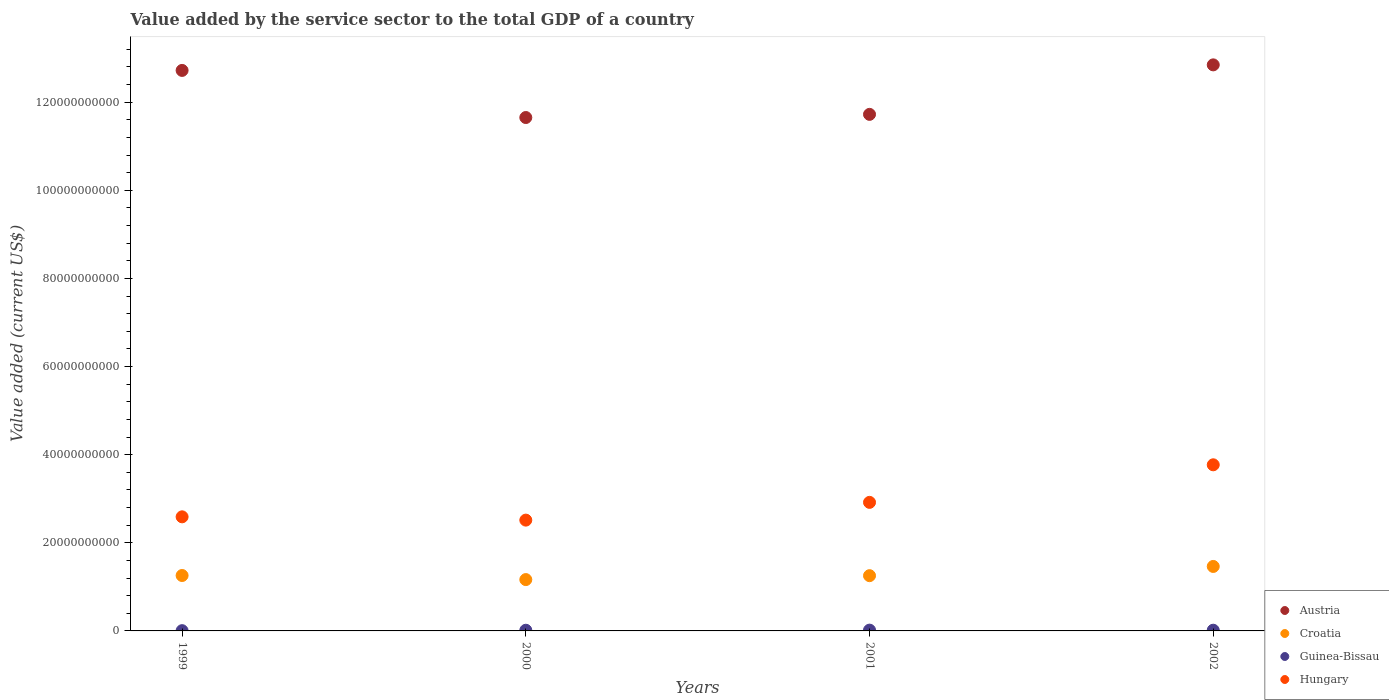How many different coloured dotlines are there?
Your response must be concise. 4. Is the number of dotlines equal to the number of legend labels?
Your answer should be compact. Yes. What is the value added by the service sector to the total GDP in Croatia in 2002?
Offer a very short reply. 1.46e+1. Across all years, what is the maximum value added by the service sector to the total GDP in Austria?
Your answer should be very brief. 1.28e+11. Across all years, what is the minimum value added by the service sector to the total GDP in Guinea-Bissau?
Keep it short and to the point. 5.98e+07. In which year was the value added by the service sector to the total GDP in Guinea-Bissau maximum?
Keep it short and to the point. 2001. In which year was the value added by the service sector to the total GDP in Guinea-Bissau minimum?
Provide a short and direct response. 1999. What is the total value added by the service sector to the total GDP in Guinea-Bissau in the graph?
Your response must be concise. 5.57e+08. What is the difference between the value added by the service sector to the total GDP in Guinea-Bissau in 1999 and that in 2001?
Provide a short and direct response. -1.21e+08. What is the difference between the value added by the service sector to the total GDP in Croatia in 2002 and the value added by the service sector to the total GDP in Austria in 1999?
Give a very brief answer. -1.13e+11. What is the average value added by the service sector to the total GDP in Guinea-Bissau per year?
Provide a succinct answer. 1.39e+08. In the year 2002, what is the difference between the value added by the service sector to the total GDP in Hungary and value added by the service sector to the total GDP in Austria?
Offer a very short reply. -9.08e+1. What is the ratio of the value added by the service sector to the total GDP in Guinea-Bissau in 2000 to that in 2001?
Provide a succinct answer. 0.86. Is the difference between the value added by the service sector to the total GDP in Hungary in 2001 and 2002 greater than the difference between the value added by the service sector to the total GDP in Austria in 2001 and 2002?
Give a very brief answer. Yes. What is the difference between the highest and the second highest value added by the service sector to the total GDP in Austria?
Offer a very short reply. 1.26e+09. What is the difference between the highest and the lowest value added by the service sector to the total GDP in Guinea-Bissau?
Ensure brevity in your answer.  1.21e+08. Is it the case that in every year, the sum of the value added by the service sector to the total GDP in Austria and value added by the service sector to the total GDP in Guinea-Bissau  is greater than the sum of value added by the service sector to the total GDP in Croatia and value added by the service sector to the total GDP in Hungary?
Provide a short and direct response. No. Is it the case that in every year, the sum of the value added by the service sector to the total GDP in Croatia and value added by the service sector to the total GDP in Guinea-Bissau  is greater than the value added by the service sector to the total GDP in Hungary?
Provide a succinct answer. No. Does the value added by the service sector to the total GDP in Croatia monotonically increase over the years?
Keep it short and to the point. No. Is the value added by the service sector to the total GDP in Austria strictly greater than the value added by the service sector to the total GDP in Guinea-Bissau over the years?
Ensure brevity in your answer.  Yes. How many dotlines are there?
Make the answer very short. 4. How many years are there in the graph?
Your answer should be compact. 4. What is the difference between two consecutive major ticks on the Y-axis?
Provide a short and direct response. 2.00e+1. Are the values on the major ticks of Y-axis written in scientific E-notation?
Give a very brief answer. No. Does the graph contain grids?
Provide a short and direct response. No. Where does the legend appear in the graph?
Your answer should be very brief. Bottom right. How are the legend labels stacked?
Your answer should be compact. Vertical. What is the title of the graph?
Your response must be concise. Value added by the service sector to the total GDP of a country. Does "Mexico" appear as one of the legend labels in the graph?
Provide a short and direct response. No. What is the label or title of the X-axis?
Provide a succinct answer. Years. What is the label or title of the Y-axis?
Your answer should be very brief. Value added (current US$). What is the Value added (current US$) of Austria in 1999?
Provide a short and direct response. 1.27e+11. What is the Value added (current US$) of Croatia in 1999?
Give a very brief answer. 1.26e+1. What is the Value added (current US$) of Guinea-Bissau in 1999?
Your response must be concise. 5.98e+07. What is the Value added (current US$) in Hungary in 1999?
Your answer should be very brief. 2.59e+1. What is the Value added (current US$) in Austria in 2000?
Offer a very short reply. 1.17e+11. What is the Value added (current US$) in Croatia in 2000?
Provide a succinct answer. 1.17e+1. What is the Value added (current US$) in Guinea-Bissau in 2000?
Your answer should be compact. 1.55e+08. What is the Value added (current US$) of Hungary in 2000?
Your answer should be very brief. 2.51e+1. What is the Value added (current US$) in Austria in 2001?
Your answer should be compact. 1.17e+11. What is the Value added (current US$) of Croatia in 2001?
Keep it short and to the point. 1.25e+1. What is the Value added (current US$) of Guinea-Bissau in 2001?
Your answer should be very brief. 1.81e+08. What is the Value added (current US$) in Hungary in 2001?
Your answer should be compact. 2.92e+1. What is the Value added (current US$) of Austria in 2002?
Keep it short and to the point. 1.28e+11. What is the Value added (current US$) in Croatia in 2002?
Make the answer very short. 1.46e+1. What is the Value added (current US$) in Guinea-Bissau in 2002?
Provide a short and direct response. 1.61e+08. What is the Value added (current US$) of Hungary in 2002?
Give a very brief answer. 3.77e+1. Across all years, what is the maximum Value added (current US$) in Austria?
Offer a very short reply. 1.28e+11. Across all years, what is the maximum Value added (current US$) in Croatia?
Your response must be concise. 1.46e+1. Across all years, what is the maximum Value added (current US$) of Guinea-Bissau?
Your answer should be compact. 1.81e+08. Across all years, what is the maximum Value added (current US$) of Hungary?
Provide a succinct answer. 3.77e+1. Across all years, what is the minimum Value added (current US$) in Austria?
Offer a terse response. 1.17e+11. Across all years, what is the minimum Value added (current US$) of Croatia?
Ensure brevity in your answer.  1.17e+1. Across all years, what is the minimum Value added (current US$) of Guinea-Bissau?
Offer a terse response. 5.98e+07. Across all years, what is the minimum Value added (current US$) of Hungary?
Provide a short and direct response. 2.51e+1. What is the total Value added (current US$) in Austria in the graph?
Keep it short and to the point. 4.89e+11. What is the total Value added (current US$) of Croatia in the graph?
Ensure brevity in your answer.  5.14e+1. What is the total Value added (current US$) in Guinea-Bissau in the graph?
Ensure brevity in your answer.  5.57e+08. What is the total Value added (current US$) of Hungary in the graph?
Provide a succinct answer. 1.18e+11. What is the difference between the Value added (current US$) of Austria in 1999 and that in 2000?
Provide a short and direct response. 1.07e+1. What is the difference between the Value added (current US$) in Croatia in 1999 and that in 2000?
Ensure brevity in your answer.  9.26e+08. What is the difference between the Value added (current US$) of Guinea-Bissau in 1999 and that in 2000?
Offer a very short reply. -9.49e+07. What is the difference between the Value added (current US$) of Hungary in 1999 and that in 2000?
Give a very brief answer. 7.47e+08. What is the difference between the Value added (current US$) of Austria in 1999 and that in 2001?
Your answer should be compact. 9.97e+09. What is the difference between the Value added (current US$) of Croatia in 1999 and that in 2001?
Offer a very short reply. 3.69e+07. What is the difference between the Value added (current US$) in Guinea-Bissau in 1999 and that in 2001?
Your response must be concise. -1.21e+08. What is the difference between the Value added (current US$) in Hungary in 1999 and that in 2001?
Your response must be concise. -3.28e+09. What is the difference between the Value added (current US$) of Austria in 1999 and that in 2002?
Your answer should be compact. -1.26e+09. What is the difference between the Value added (current US$) of Croatia in 1999 and that in 2002?
Offer a terse response. -2.06e+09. What is the difference between the Value added (current US$) of Guinea-Bissau in 1999 and that in 2002?
Your answer should be very brief. -1.02e+08. What is the difference between the Value added (current US$) in Hungary in 1999 and that in 2002?
Ensure brevity in your answer.  -1.18e+1. What is the difference between the Value added (current US$) in Austria in 2000 and that in 2001?
Provide a succinct answer. -7.18e+08. What is the difference between the Value added (current US$) in Croatia in 2000 and that in 2001?
Your answer should be very brief. -8.89e+08. What is the difference between the Value added (current US$) of Guinea-Bissau in 2000 and that in 2001?
Provide a short and direct response. -2.60e+07. What is the difference between the Value added (current US$) in Hungary in 2000 and that in 2001?
Give a very brief answer. -4.03e+09. What is the difference between the Value added (current US$) of Austria in 2000 and that in 2002?
Your answer should be very brief. -1.20e+1. What is the difference between the Value added (current US$) in Croatia in 2000 and that in 2002?
Your answer should be compact. -2.98e+09. What is the difference between the Value added (current US$) in Guinea-Bissau in 2000 and that in 2002?
Keep it short and to the point. -6.68e+06. What is the difference between the Value added (current US$) of Hungary in 2000 and that in 2002?
Your answer should be very brief. -1.26e+1. What is the difference between the Value added (current US$) of Austria in 2001 and that in 2002?
Your answer should be very brief. -1.12e+1. What is the difference between the Value added (current US$) of Croatia in 2001 and that in 2002?
Provide a short and direct response. -2.09e+09. What is the difference between the Value added (current US$) in Guinea-Bissau in 2001 and that in 2002?
Give a very brief answer. 1.93e+07. What is the difference between the Value added (current US$) of Hungary in 2001 and that in 2002?
Provide a short and direct response. -8.53e+09. What is the difference between the Value added (current US$) of Austria in 1999 and the Value added (current US$) of Croatia in 2000?
Your answer should be compact. 1.16e+11. What is the difference between the Value added (current US$) in Austria in 1999 and the Value added (current US$) in Guinea-Bissau in 2000?
Offer a very short reply. 1.27e+11. What is the difference between the Value added (current US$) of Austria in 1999 and the Value added (current US$) of Hungary in 2000?
Give a very brief answer. 1.02e+11. What is the difference between the Value added (current US$) of Croatia in 1999 and the Value added (current US$) of Guinea-Bissau in 2000?
Your answer should be compact. 1.24e+1. What is the difference between the Value added (current US$) in Croatia in 1999 and the Value added (current US$) in Hungary in 2000?
Keep it short and to the point. -1.26e+1. What is the difference between the Value added (current US$) of Guinea-Bissau in 1999 and the Value added (current US$) of Hungary in 2000?
Make the answer very short. -2.51e+1. What is the difference between the Value added (current US$) in Austria in 1999 and the Value added (current US$) in Croatia in 2001?
Your response must be concise. 1.15e+11. What is the difference between the Value added (current US$) in Austria in 1999 and the Value added (current US$) in Guinea-Bissau in 2001?
Provide a succinct answer. 1.27e+11. What is the difference between the Value added (current US$) in Austria in 1999 and the Value added (current US$) in Hungary in 2001?
Make the answer very short. 9.80e+1. What is the difference between the Value added (current US$) in Croatia in 1999 and the Value added (current US$) in Guinea-Bissau in 2001?
Keep it short and to the point. 1.24e+1. What is the difference between the Value added (current US$) of Croatia in 1999 and the Value added (current US$) of Hungary in 2001?
Give a very brief answer. -1.66e+1. What is the difference between the Value added (current US$) in Guinea-Bissau in 1999 and the Value added (current US$) in Hungary in 2001?
Your response must be concise. -2.91e+1. What is the difference between the Value added (current US$) of Austria in 1999 and the Value added (current US$) of Croatia in 2002?
Provide a succinct answer. 1.13e+11. What is the difference between the Value added (current US$) in Austria in 1999 and the Value added (current US$) in Guinea-Bissau in 2002?
Give a very brief answer. 1.27e+11. What is the difference between the Value added (current US$) in Austria in 1999 and the Value added (current US$) in Hungary in 2002?
Offer a terse response. 8.95e+1. What is the difference between the Value added (current US$) in Croatia in 1999 and the Value added (current US$) in Guinea-Bissau in 2002?
Provide a short and direct response. 1.24e+1. What is the difference between the Value added (current US$) in Croatia in 1999 and the Value added (current US$) in Hungary in 2002?
Offer a terse response. -2.51e+1. What is the difference between the Value added (current US$) of Guinea-Bissau in 1999 and the Value added (current US$) of Hungary in 2002?
Offer a terse response. -3.76e+1. What is the difference between the Value added (current US$) in Austria in 2000 and the Value added (current US$) in Croatia in 2001?
Give a very brief answer. 1.04e+11. What is the difference between the Value added (current US$) in Austria in 2000 and the Value added (current US$) in Guinea-Bissau in 2001?
Your answer should be very brief. 1.16e+11. What is the difference between the Value added (current US$) in Austria in 2000 and the Value added (current US$) in Hungary in 2001?
Your answer should be compact. 8.73e+1. What is the difference between the Value added (current US$) in Croatia in 2000 and the Value added (current US$) in Guinea-Bissau in 2001?
Give a very brief answer. 1.15e+1. What is the difference between the Value added (current US$) of Croatia in 2000 and the Value added (current US$) of Hungary in 2001?
Your response must be concise. -1.75e+1. What is the difference between the Value added (current US$) of Guinea-Bissau in 2000 and the Value added (current US$) of Hungary in 2001?
Your answer should be compact. -2.90e+1. What is the difference between the Value added (current US$) of Austria in 2000 and the Value added (current US$) of Croatia in 2002?
Offer a terse response. 1.02e+11. What is the difference between the Value added (current US$) in Austria in 2000 and the Value added (current US$) in Guinea-Bissau in 2002?
Keep it short and to the point. 1.16e+11. What is the difference between the Value added (current US$) in Austria in 2000 and the Value added (current US$) in Hungary in 2002?
Provide a short and direct response. 7.88e+1. What is the difference between the Value added (current US$) of Croatia in 2000 and the Value added (current US$) of Guinea-Bissau in 2002?
Keep it short and to the point. 1.15e+1. What is the difference between the Value added (current US$) in Croatia in 2000 and the Value added (current US$) in Hungary in 2002?
Give a very brief answer. -2.61e+1. What is the difference between the Value added (current US$) of Guinea-Bissau in 2000 and the Value added (current US$) of Hungary in 2002?
Offer a very short reply. -3.76e+1. What is the difference between the Value added (current US$) in Austria in 2001 and the Value added (current US$) in Croatia in 2002?
Provide a short and direct response. 1.03e+11. What is the difference between the Value added (current US$) in Austria in 2001 and the Value added (current US$) in Guinea-Bissau in 2002?
Your answer should be very brief. 1.17e+11. What is the difference between the Value added (current US$) of Austria in 2001 and the Value added (current US$) of Hungary in 2002?
Your response must be concise. 7.95e+1. What is the difference between the Value added (current US$) of Croatia in 2001 and the Value added (current US$) of Guinea-Bissau in 2002?
Your answer should be compact. 1.24e+1. What is the difference between the Value added (current US$) of Croatia in 2001 and the Value added (current US$) of Hungary in 2002?
Give a very brief answer. -2.52e+1. What is the difference between the Value added (current US$) of Guinea-Bissau in 2001 and the Value added (current US$) of Hungary in 2002?
Give a very brief answer. -3.75e+1. What is the average Value added (current US$) in Austria per year?
Your answer should be very brief. 1.22e+11. What is the average Value added (current US$) in Croatia per year?
Keep it short and to the point. 1.29e+1. What is the average Value added (current US$) of Guinea-Bissau per year?
Your answer should be very brief. 1.39e+08. What is the average Value added (current US$) of Hungary per year?
Offer a very short reply. 2.95e+1. In the year 1999, what is the difference between the Value added (current US$) in Austria and Value added (current US$) in Croatia?
Your answer should be compact. 1.15e+11. In the year 1999, what is the difference between the Value added (current US$) in Austria and Value added (current US$) in Guinea-Bissau?
Make the answer very short. 1.27e+11. In the year 1999, what is the difference between the Value added (current US$) of Austria and Value added (current US$) of Hungary?
Make the answer very short. 1.01e+11. In the year 1999, what is the difference between the Value added (current US$) of Croatia and Value added (current US$) of Guinea-Bissau?
Your answer should be very brief. 1.25e+1. In the year 1999, what is the difference between the Value added (current US$) in Croatia and Value added (current US$) in Hungary?
Keep it short and to the point. -1.33e+1. In the year 1999, what is the difference between the Value added (current US$) of Guinea-Bissau and Value added (current US$) of Hungary?
Ensure brevity in your answer.  -2.58e+1. In the year 2000, what is the difference between the Value added (current US$) in Austria and Value added (current US$) in Croatia?
Ensure brevity in your answer.  1.05e+11. In the year 2000, what is the difference between the Value added (current US$) in Austria and Value added (current US$) in Guinea-Bissau?
Your answer should be very brief. 1.16e+11. In the year 2000, what is the difference between the Value added (current US$) of Austria and Value added (current US$) of Hungary?
Give a very brief answer. 9.14e+1. In the year 2000, what is the difference between the Value added (current US$) in Croatia and Value added (current US$) in Guinea-Bissau?
Provide a succinct answer. 1.15e+1. In the year 2000, what is the difference between the Value added (current US$) of Croatia and Value added (current US$) of Hungary?
Your answer should be very brief. -1.35e+1. In the year 2000, what is the difference between the Value added (current US$) in Guinea-Bissau and Value added (current US$) in Hungary?
Your answer should be compact. -2.50e+1. In the year 2001, what is the difference between the Value added (current US$) in Austria and Value added (current US$) in Croatia?
Provide a short and direct response. 1.05e+11. In the year 2001, what is the difference between the Value added (current US$) of Austria and Value added (current US$) of Guinea-Bissau?
Your answer should be very brief. 1.17e+11. In the year 2001, what is the difference between the Value added (current US$) in Austria and Value added (current US$) in Hungary?
Offer a terse response. 8.81e+1. In the year 2001, what is the difference between the Value added (current US$) in Croatia and Value added (current US$) in Guinea-Bissau?
Offer a terse response. 1.24e+1. In the year 2001, what is the difference between the Value added (current US$) in Croatia and Value added (current US$) in Hungary?
Provide a succinct answer. -1.66e+1. In the year 2001, what is the difference between the Value added (current US$) in Guinea-Bissau and Value added (current US$) in Hungary?
Keep it short and to the point. -2.90e+1. In the year 2002, what is the difference between the Value added (current US$) in Austria and Value added (current US$) in Croatia?
Your answer should be very brief. 1.14e+11. In the year 2002, what is the difference between the Value added (current US$) of Austria and Value added (current US$) of Guinea-Bissau?
Ensure brevity in your answer.  1.28e+11. In the year 2002, what is the difference between the Value added (current US$) in Austria and Value added (current US$) in Hungary?
Your answer should be very brief. 9.08e+1. In the year 2002, what is the difference between the Value added (current US$) in Croatia and Value added (current US$) in Guinea-Bissau?
Make the answer very short. 1.45e+1. In the year 2002, what is the difference between the Value added (current US$) of Croatia and Value added (current US$) of Hungary?
Offer a very short reply. -2.31e+1. In the year 2002, what is the difference between the Value added (current US$) in Guinea-Bissau and Value added (current US$) in Hungary?
Offer a terse response. -3.75e+1. What is the ratio of the Value added (current US$) of Austria in 1999 to that in 2000?
Provide a succinct answer. 1.09. What is the ratio of the Value added (current US$) in Croatia in 1999 to that in 2000?
Keep it short and to the point. 1.08. What is the ratio of the Value added (current US$) of Guinea-Bissau in 1999 to that in 2000?
Give a very brief answer. 0.39. What is the ratio of the Value added (current US$) in Hungary in 1999 to that in 2000?
Provide a succinct answer. 1.03. What is the ratio of the Value added (current US$) in Austria in 1999 to that in 2001?
Ensure brevity in your answer.  1.09. What is the ratio of the Value added (current US$) in Croatia in 1999 to that in 2001?
Your answer should be very brief. 1. What is the ratio of the Value added (current US$) in Guinea-Bissau in 1999 to that in 2001?
Your answer should be compact. 0.33. What is the ratio of the Value added (current US$) of Hungary in 1999 to that in 2001?
Provide a short and direct response. 0.89. What is the ratio of the Value added (current US$) of Austria in 1999 to that in 2002?
Your answer should be compact. 0.99. What is the ratio of the Value added (current US$) of Croatia in 1999 to that in 2002?
Offer a terse response. 0.86. What is the ratio of the Value added (current US$) of Guinea-Bissau in 1999 to that in 2002?
Provide a short and direct response. 0.37. What is the ratio of the Value added (current US$) of Hungary in 1999 to that in 2002?
Your answer should be very brief. 0.69. What is the ratio of the Value added (current US$) of Croatia in 2000 to that in 2001?
Offer a terse response. 0.93. What is the ratio of the Value added (current US$) of Guinea-Bissau in 2000 to that in 2001?
Keep it short and to the point. 0.86. What is the ratio of the Value added (current US$) of Hungary in 2000 to that in 2001?
Make the answer very short. 0.86. What is the ratio of the Value added (current US$) of Austria in 2000 to that in 2002?
Your answer should be compact. 0.91. What is the ratio of the Value added (current US$) of Croatia in 2000 to that in 2002?
Make the answer very short. 0.8. What is the ratio of the Value added (current US$) in Guinea-Bissau in 2000 to that in 2002?
Keep it short and to the point. 0.96. What is the ratio of the Value added (current US$) of Hungary in 2000 to that in 2002?
Provide a short and direct response. 0.67. What is the ratio of the Value added (current US$) in Austria in 2001 to that in 2002?
Make the answer very short. 0.91. What is the ratio of the Value added (current US$) of Croatia in 2001 to that in 2002?
Ensure brevity in your answer.  0.86. What is the ratio of the Value added (current US$) in Guinea-Bissau in 2001 to that in 2002?
Make the answer very short. 1.12. What is the ratio of the Value added (current US$) in Hungary in 2001 to that in 2002?
Your response must be concise. 0.77. What is the difference between the highest and the second highest Value added (current US$) of Austria?
Provide a short and direct response. 1.26e+09. What is the difference between the highest and the second highest Value added (current US$) in Croatia?
Provide a succinct answer. 2.06e+09. What is the difference between the highest and the second highest Value added (current US$) in Guinea-Bissau?
Your answer should be compact. 1.93e+07. What is the difference between the highest and the second highest Value added (current US$) of Hungary?
Offer a very short reply. 8.53e+09. What is the difference between the highest and the lowest Value added (current US$) in Austria?
Your answer should be compact. 1.20e+1. What is the difference between the highest and the lowest Value added (current US$) of Croatia?
Offer a terse response. 2.98e+09. What is the difference between the highest and the lowest Value added (current US$) of Guinea-Bissau?
Offer a very short reply. 1.21e+08. What is the difference between the highest and the lowest Value added (current US$) in Hungary?
Your response must be concise. 1.26e+1. 